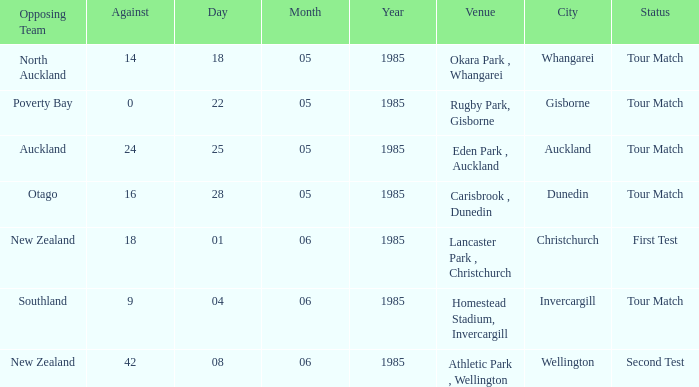Which venue had an against score smaller than 18 when the opposing team was North Auckland? Okara Park , Whangarei. 